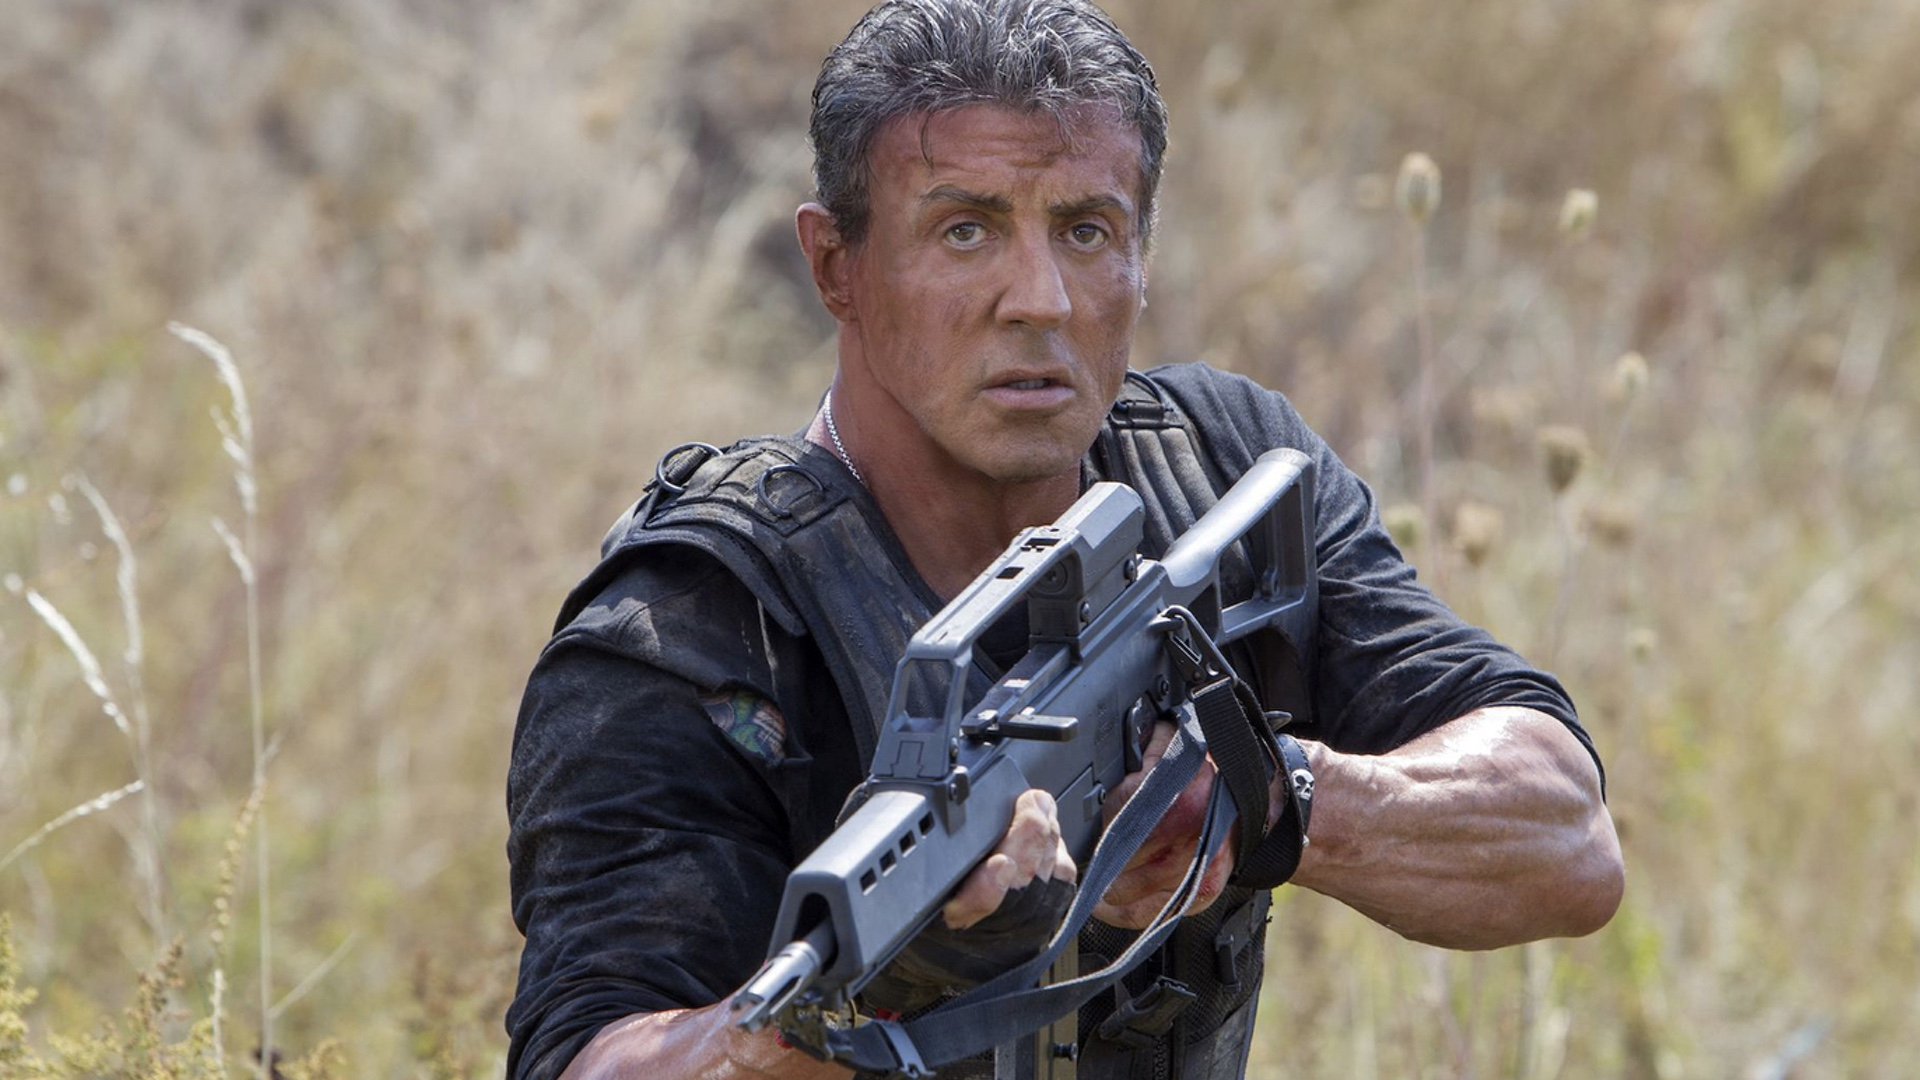Envision a realistic scenario in this sharegpt4v/same setting where Rambo's instincts are put to the test. In the stillness of the field, Rambo's seasoned ears pick up the faint rustle of something or someone moving through the tall grass behind him. His eyes narrow, and he shifts his weight quietly, preparing to act. Suddenly, a squad of enemy soldiers emerges, spreading out in a tactical formation. With swift precision, Rambo assesses the situation and formulates a plan. He rolls into a nearby ditch, taking cover while staying perfectly silent. Using his surroundings to his advantage, he begins to systematically neutralize the threats one by one, his movements calculated and his face an unreadable mask of concentration. 